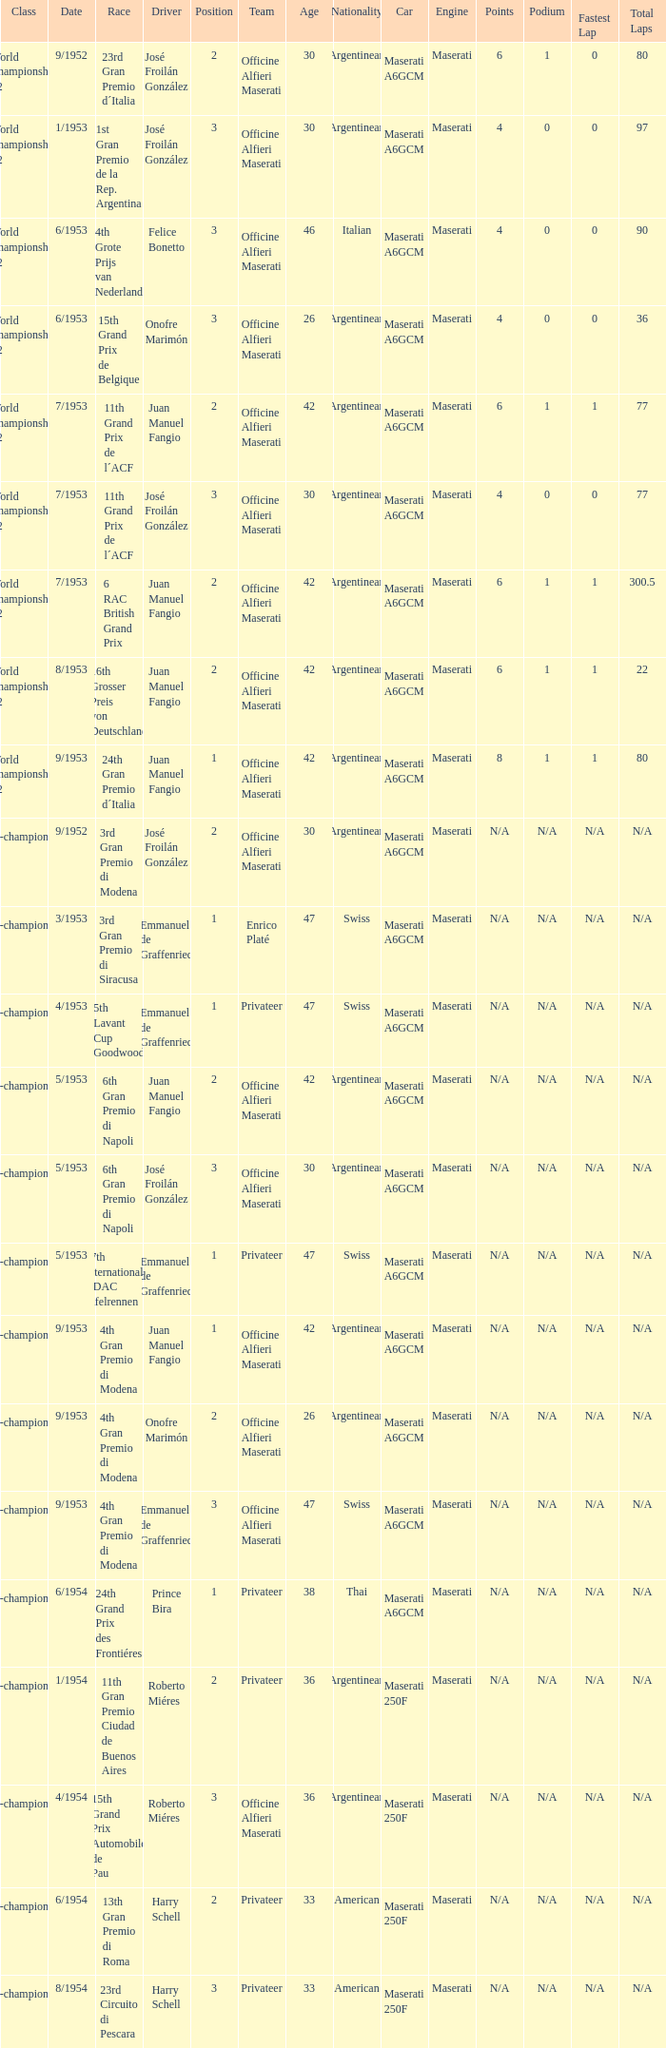What date has the class of non-championship f2 as well as a driver name josé froilán gonzález that has a position larger than 2? 5/1953. 